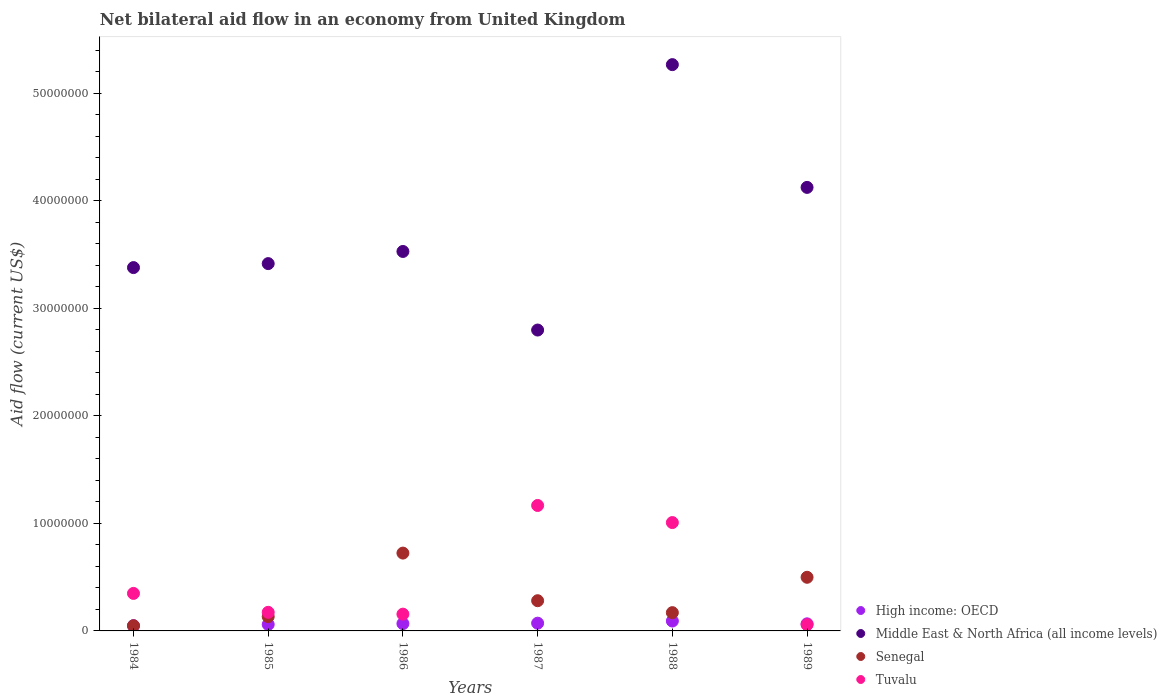How many different coloured dotlines are there?
Your answer should be compact. 4. Is the number of dotlines equal to the number of legend labels?
Your answer should be compact. Yes. What is the net bilateral aid flow in Senegal in 1985?
Your response must be concise. 1.33e+06. Across all years, what is the maximum net bilateral aid flow in Senegal?
Your response must be concise. 7.24e+06. In which year was the net bilateral aid flow in High income: OECD maximum?
Your answer should be compact. 1988. What is the total net bilateral aid flow in Middle East & North Africa (all income levels) in the graph?
Ensure brevity in your answer.  2.25e+08. What is the difference between the net bilateral aid flow in Senegal in 1987 and that in 1989?
Ensure brevity in your answer.  -2.18e+06. What is the difference between the net bilateral aid flow in Senegal in 1985 and the net bilateral aid flow in Middle East & North Africa (all income levels) in 1988?
Keep it short and to the point. -5.14e+07. What is the average net bilateral aid flow in Tuvalu per year?
Provide a short and direct response. 4.85e+06. In the year 1988, what is the difference between the net bilateral aid flow in Tuvalu and net bilateral aid flow in Senegal?
Keep it short and to the point. 8.38e+06. In how many years, is the net bilateral aid flow in High income: OECD greater than 28000000 US$?
Give a very brief answer. 0. What is the ratio of the net bilateral aid flow in Tuvalu in 1988 to that in 1989?
Offer a terse response. 17.38. Is the net bilateral aid flow in Middle East & North Africa (all income levels) in 1985 less than that in 1988?
Offer a very short reply. Yes. Is the difference between the net bilateral aid flow in Tuvalu in 1987 and 1988 greater than the difference between the net bilateral aid flow in Senegal in 1987 and 1988?
Your answer should be compact. Yes. What is the difference between the highest and the second highest net bilateral aid flow in Tuvalu?
Give a very brief answer. 1.59e+06. What is the difference between the highest and the lowest net bilateral aid flow in Senegal?
Provide a short and direct response. 6.76e+06. In how many years, is the net bilateral aid flow in Middle East & North Africa (all income levels) greater than the average net bilateral aid flow in Middle East & North Africa (all income levels) taken over all years?
Make the answer very short. 2. Is the sum of the net bilateral aid flow in Senegal in 1985 and 1988 greater than the maximum net bilateral aid flow in High income: OECD across all years?
Provide a succinct answer. Yes. Is it the case that in every year, the sum of the net bilateral aid flow in Senegal and net bilateral aid flow in High income: OECD  is greater than the net bilateral aid flow in Middle East & North Africa (all income levels)?
Offer a terse response. No. What is the title of the graph?
Give a very brief answer. Net bilateral aid flow in an economy from United Kingdom. Does "Korea (Democratic)" appear as one of the legend labels in the graph?
Provide a succinct answer. No. What is the label or title of the Y-axis?
Offer a terse response. Aid flow (current US$). What is the Aid flow (current US$) of High income: OECD in 1984?
Offer a terse response. 4.90e+05. What is the Aid flow (current US$) in Middle East & North Africa (all income levels) in 1984?
Provide a short and direct response. 3.38e+07. What is the Aid flow (current US$) in Senegal in 1984?
Offer a terse response. 4.80e+05. What is the Aid flow (current US$) in Tuvalu in 1984?
Provide a short and direct response. 3.49e+06. What is the Aid flow (current US$) in High income: OECD in 1985?
Offer a terse response. 6.00e+05. What is the Aid flow (current US$) in Middle East & North Africa (all income levels) in 1985?
Offer a terse response. 3.42e+07. What is the Aid flow (current US$) of Senegal in 1985?
Give a very brief answer. 1.33e+06. What is the Aid flow (current US$) in Tuvalu in 1985?
Offer a terse response. 1.73e+06. What is the Aid flow (current US$) in High income: OECD in 1986?
Ensure brevity in your answer.  6.80e+05. What is the Aid flow (current US$) in Middle East & North Africa (all income levels) in 1986?
Your answer should be very brief. 3.53e+07. What is the Aid flow (current US$) of Senegal in 1986?
Ensure brevity in your answer.  7.24e+06. What is the Aid flow (current US$) of Tuvalu in 1986?
Give a very brief answer. 1.56e+06. What is the Aid flow (current US$) of High income: OECD in 1987?
Provide a succinct answer. 7.20e+05. What is the Aid flow (current US$) in Middle East & North Africa (all income levels) in 1987?
Keep it short and to the point. 2.80e+07. What is the Aid flow (current US$) in Senegal in 1987?
Provide a succinct answer. 2.81e+06. What is the Aid flow (current US$) in Tuvalu in 1987?
Give a very brief answer. 1.17e+07. What is the Aid flow (current US$) in High income: OECD in 1988?
Provide a short and direct response. 9.20e+05. What is the Aid flow (current US$) in Middle East & North Africa (all income levels) in 1988?
Offer a terse response. 5.27e+07. What is the Aid flow (current US$) of Senegal in 1988?
Make the answer very short. 1.70e+06. What is the Aid flow (current US$) of Tuvalu in 1988?
Your response must be concise. 1.01e+07. What is the Aid flow (current US$) in High income: OECD in 1989?
Make the answer very short. 6.60e+05. What is the Aid flow (current US$) in Middle East & North Africa (all income levels) in 1989?
Provide a short and direct response. 4.13e+07. What is the Aid flow (current US$) of Senegal in 1989?
Your response must be concise. 4.99e+06. What is the Aid flow (current US$) of Tuvalu in 1989?
Make the answer very short. 5.80e+05. Across all years, what is the maximum Aid flow (current US$) of High income: OECD?
Your answer should be compact. 9.20e+05. Across all years, what is the maximum Aid flow (current US$) in Middle East & North Africa (all income levels)?
Offer a very short reply. 5.27e+07. Across all years, what is the maximum Aid flow (current US$) in Senegal?
Offer a very short reply. 7.24e+06. Across all years, what is the maximum Aid flow (current US$) in Tuvalu?
Provide a short and direct response. 1.17e+07. Across all years, what is the minimum Aid flow (current US$) of High income: OECD?
Offer a very short reply. 4.90e+05. Across all years, what is the minimum Aid flow (current US$) of Middle East & North Africa (all income levels)?
Keep it short and to the point. 2.80e+07. Across all years, what is the minimum Aid flow (current US$) in Tuvalu?
Offer a terse response. 5.80e+05. What is the total Aid flow (current US$) in High income: OECD in the graph?
Your answer should be compact. 4.07e+06. What is the total Aid flow (current US$) of Middle East & North Africa (all income levels) in the graph?
Give a very brief answer. 2.25e+08. What is the total Aid flow (current US$) of Senegal in the graph?
Provide a short and direct response. 1.86e+07. What is the total Aid flow (current US$) in Tuvalu in the graph?
Your answer should be very brief. 2.91e+07. What is the difference between the Aid flow (current US$) of Middle East & North Africa (all income levels) in 1984 and that in 1985?
Keep it short and to the point. -3.70e+05. What is the difference between the Aid flow (current US$) of Senegal in 1984 and that in 1985?
Give a very brief answer. -8.50e+05. What is the difference between the Aid flow (current US$) of Tuvalu in 1984 and that in 1985?
Offer a terse response. 1.76e+06. What is the difference between the Aid flow (current US$) in High income: OECD in 1984 and that in 1986?
Your response must be concise. -1.90e+05. What is the difference between the Aid flow (current US$) in Middle East & North Africa (all income levels) in 1984 and that in 1986?
Offer a terse response. -1.50e+06. What is the difference between the Aid flow (current US$) of Senegal in 1984 and that in 1986?
Provide a short and direct response. -6.76e+06. What is the difference between the Aid flow (current US$) of Tuvalu in 1984 and that in 1986?
Provide a short and direct response. 1.93e+06. What is the difference between the Aid flow (current US$) in Middle East & North Africa (all income levels) in 1984 and that in 1987?
Make the answer very short. 5.81e+06. What is the difference between the Aid flow (current US$) in Senegal in 1984 and that in 1987?
Your answer should be very brief. -2.33e+06. What is the difference between the Aid flow (current US$) of Tuvalu in 1984 and that in 1987?
Your response must be concise. -8.18e+06. What is the difference between the Aid flow (current US$) of High income: OECD in 1984 and that in 1988?
Your answer should be compact. -4.30e+05. What is the difference between the Aid flow (current US$) of Middle East & North Africa (all income levels) in 1984 and that in 1988?
Provide a succinct answer. -1.89e+07. What is the difference between the Aid flow (current US$) in Senegal in 1984 and that in 1988?
Offer a very short reply. -1.22e+06. What is the difference between the Aid flow (current US$) of Tuvalu in 1984 and that in 1988?
Provide a succinct answer. -6.59e+06. What is the difference between the Aid flow (current US$) in Middle East & North Africa (all income levels) in 1984 and that in 1989?
Ensure brevity in your answer.  -7.46e+06. What is the difference between the Aid flow (current US$) of Senegal in 1984 and that in 1989?
Provide a succinct answer. -4.51e+06. What is the difference between the Aid flow (current US$) of Tuvalu in 1984 and that in 1989?
Give a very brief answer. 2.91e+06. What is the difference between the Aid flow (current US$) in Middle East & North Africa (all income levels) in 1985 and that in 1986?
Your answer should be very brief. -1.13e+06. What is the difference between the Aid flow (current US$) of Senegal in 1985 and that in 1986?
Your answer should be very brief. -5.91e+06. What is the difference between the Aid flow (current US$) of Tuvalu in 1985 and that in 1986?
Provide a short and direct response. 1.70e+05. What is the difference between the Aid flow (current US$) in High income: OECD in 1985 and that in 1987?
Provide a short and direct response. -1.20e+05. What is the difference between the Aid flow (current US$) of Middle East & North Africa (all income levels) in 1985 and that in 1987?
Give a very brief answer. 6.18e+06. What is the difference between the Aid flow (current US$) of Senegal in 1985 and that in 1987?
Keep it short and to the point. -1.48e+06. What is the difference between the Aid flow (current US$) in Tuvalu in 1985 and that in 1987?
Offer a very short reply. -9.94e+06. What is the difference between the Aid flow (current US$) in High income: OECD in 1985 and that in 1988?
Provide a short and direct response. -3.20e+05. What is the difference between the Aid flow (current US$) of Middle East & North Africa (all income levels) in 1985 and that in 1988?
Provide a succinct answer. -1.85e+07. What is the difference between the Aid flow (current US$) of Senegal in 1985 and that in 1988?
Ensure brevity in your answer.  -3.70e+05. What is the difference between the Aid flow (current US$) in Tuvalu in 1985 and that in 1988?
Give a very brief answer. -8.35e+06. What is the difference between the Aid flow (current US$) of Middle East & North Africa (all income levels) in 1985 and that in 1989?
Your answer should be very brief. -7.09e+06. What is the difference between the Aid flow (current US$) in Senegal in 1985 and that in 1989?
Provide a succinct answer. -3.66e+06. What is the difference between the Aid flow (current US$) of Tuvalu in 1985 and that in 1989?
Give a very brief answer. 1.15e+06. What is the difference between the Aid flow (current US$) in High income: OECD in 1986 and that in 1987?
Your answer should be compact. -4.00e+04. What is the difference between the Aid flow (current US$) in Middle East & North Africa (all income levels) in 1986 and that in 1987?
Provide a succinct answer. 7.31e+06. What is the difference between the Aid flow (current US$) in Senegal in 1986 and that in 1987?
Give a very brief answer. 4.43e+06. What is the difference between the Aid flow (current US$) of Tuvalu in 1986 and that in 1987?
Keep it short and to the point. -1.01e+07. What is the difference between the Aid flow (current US$) in Middle East & North Africa (all income levels) in 1986 and that in 1988?
Ensure brevity in your answer.  -1.74e+07. What is the difference between the Aid flow (current US$) in Senegal in 1986 and that in 1988?
Your answer should be very brief. 5.54e+06. What is the difference between the Aid flow (current US$) of Tuvalu in 1986 and that in 1988?
Your answer should be very brief. -8.52e+06. What is the difference between the Aid flow (current US$) in Middle East & North Africa (all income levels) in 1986 and that in 1989?
Provide a succinct answer. -5.96e+06. What is the difference between the Aid flow (current US$) of Senegal in 1986 and that in 1989?
Give a very brief answer. 2.25e+06. What is the difference between the Aid flow (current US$) in Tuvalu in 1986 and that in 1989?
Your response must be concise. 9.80e+05. What is the difference between the Aid flow (current US$) in Middle East & North Africa (all income levels) in 1987 and that in 1988?
Make the answer very short. -2.47e+07. What is the difference between the Aid flow (current US$) of Senegal in 1987 and that in 1988?
Provide a succinct answer. 1.11e+06. What is the difference between the Aid flow (current US$) of Tuvalu in 1987 and that in 1988?
Provide a short and direct response. 1.59e+06. What is the difference between the Aid flow (current US$) of High income: OECD in 1987 and that in 1989?
Keep it short and to the point. 6.00e+04. What is the difference between the Aid flow (current US$) of Middle East & North Africa (all income levels) in 1987 and that in 1989?
Make the answer very short. -1.33e+07. What is the difference between the Aid flow (current US$) of Senegal in 1987 and that in 1989?
Offer a very short reply. -2.18e+06. What is the difference between the Aid flow (current US$) in Tuvalu in 1987 and that in 1989?
Keep it short and to the point. 1.11e+07. What is the difference between the Aid flow (current US$) in High income: OECD in 1988 and that in 1989?
Offer a terse response. 2.60e+05. What is the difference between the Aid flow (current US$) in Middle East & North Africa (all income levels) in 1988 and that in 1989?
Provide a short and direct response. 1.14e+07. What is the difference between the Aid flow (current US$) of Senegal in 1988 and that in 1989?
Offer a terse response. -3.29e+06. What is the difference between the Aid flow (current US$) in Tuvalu in 1988 and that in 1989?
Your answer should be very brief. 9.50e+06. What is the difference between the Aid flow (current US$) of High income: OECD in 1984 and the Aid flow (current US$) of Middle East & North Africa (all income levels) in 1985?
Ensure brevity in your answer.  -3.37e+07. What is the difference between the Aid flow (current US$) of High income: OECD in 1984 and the Aid flow (current US$) of Senegal in 1985?
Your answer should be very brief. -8.40e+05. What is the difference between the Aid flow (current US$) of High income: OECD in 1984 and the Aid flow (current US$) of Tuvalu in 1985?
Offer a terse response. -1.24e+06. What is the difference between the Aid flow (current US$) in Middle East & North Africa (all income levels) in 1984 and the Aid flow (current US$) in Senegal in 1985?
Offer a very short reply. 3.25e+07. What is the difference between the Aid flow (current US$) of Middle East & North Africa (all income levels) in 1984 and the Aid flow (current US$) of Tuvalu in 1985?
Make the answer very short. 3.21e+07. What is the difference between the Aid flow (current US$) of Senegal in 1984 and the Aid flow (current US$) of Tuvalu in 1985?
Your response must be concise. -1.25e+06. What is the difference between the Aid flow (current US$) of High income: OECD in 1984 and the Aid flow (current US$) of Middle East & North Africa (all income levels) in 1986?
Make the answer very short. -3.48e+07. What is the difference between the Aid flow (current US$) of High income: OECD in 1984 and the Aid flow (current US$) of Senegal in 1986?
Make the answer very short. -6.75e+06. What is the difference between the Aid flow (current US$) of High income: OECD in 1984 and the Aid flow (current US$) of Tuvalu in 1986?
Offer a terse response. -1.07e+06. What is the difference between the Aid flow (current US$) in Middle East & North Africa (all income levels) in 1984 and the Aid flow (current US$) in Senegal in 1986?
Your answer should be compact. 2.66e+07. What is the difference between the Aid flow (current US$) in Middle East & North Africa (all income levels) in 1984 and the Aid flow (current US$) in Tuvalu in 1986?
Keep it short and to the point. 3.22e+07. What is the difference between the Aid flow (current US$) in Senegal in 1984 and the Aid flow (current US$) in Tuvalu in 1986?
Ensure brevity in your answer.  -1.08e+06. What is the difference between the Aid flow (current US$) of High income: OECD in 1984 and the Aid flow (current US$) of Middle East & North Africa (all income levels) in 1987?
Your response must be concise. -2.75e+07. What is the difference between the Aid flow (current US$) in High income: OECD in 1984 and the Aid flow (current US$) in Senegal in 1987?
Your response must be concise. -2.32e+06. What is the difference between the Aid flow (current US$) in High income: OECD in 1984 and the Aid flow (current US$) in Tuvalu in 1987?
Your answer should be very brief. -1.12e+07. What is the difference between the Aid flow (current US$) in Middle East & North Africa (all income levels) in 1984 and the Aid flow (current US$) in Senegal in 1987?
Offer a terse response. 3.10e+07. What is the difference between the Aid flow (current US$) of Middle East & North Africa (all income levels) in 1984 and the Aid flow (current US$) of Tuvalu in 1987?
Your answer should be very brief. 2.21e+07. What is the difference between the Aid flow (current US$) of Senegal in 1984 and the Aid flow (current US$) of Tuvalu in 1987?
Make the answer very short. -1.12e+07. What is the difference between the Aid flow (current US$) in High income: OECD in 1984 and the Aid flow (current US$) in Middle East & North Africa (all income levels) in 1988?
Make the answer very short. -5.22e+07. What is the difference between the Aid flow (current US$) of High income: OECD in 1984 and the Aid flow (current US$) of Senegal in 1988?
Give a very brief answer. -1.21e+06. What is the difference between the Aid flow (current US$) of High income: OECD in 1984 and the Aid flow (current US$) of Tuvalu in 1988?
Offer a very short reply. -9.59e+06. What is the difference between the Aid flow (current US$) of Middle East & North Africa (all income levels) in 1984 and the Aid flow (current US$) of Senegal in 1988?
Ensure brevity in your answer.  3.21e+07. What is the difference between the Aid flow (current US$) in Middle East & North Africa (all income levels) in 1984 and the Aid flow (current US$) in Tuvalu in 1988?
Give a very brief answer. 2.37e+07. What is the difference between the Aid flow (current US$) of Senegal in 1984 and the Aid flow (current US$) of Tuvalu in 1988?
Ensure brevity in your answer.  -9.60e+06. What is the difference between the Aid flow (current US$) of High income: OECD in 1984 and the Aid flow (current US$) of Middle East & North Africa (all income levels) in 1989?
Your response must be concise. -4.08e+07. What is the difference between the Aid flow (current US$) in High income: OECD in 1984 and the Aid flow (current US$) in Senegal in 1989?
Offer a very short reply. -4.50e+06. What is the difference between the Aid flow (current US$) in High income: OECD in 1984 and the Aid flow (current US$) in Tuvalu in 1989?
Ensure brevity in your answer.  -9.00e+04. What is the difference between the Aid flow (current US$) in Middle East & North Africa (all income levels) in 1984 and the Aid flow (current US$) in Senegal in 1989?
Make the answer very short. 2.88e+07. What is the difference between the Aid flow (current US$) of Middle East & North Africa (all income levels) in 1984 and the Aid flow (current US$) of Tuvalu in 1989?
Your response must be concise. 3.32e+07. What is the difference between the Aid flow (current US$) of High income: OECD in 1985 and the Aid flow (current US$) of Middle East & North Africa (all income levels) in 1986?
Offer a very short reply. -3.47e+07. What is the difference between the Aid flow (current US$) of High income: OECD in 1985 and the Aid flow (current US$) of Senegal in 1986?
Give a very brief answer. -6.64e+06. What is the difference between the Aid flow (current US$) of High income: OECD in 1985 and the Aid flow (current US$) of Tuvalu in 1986?
Your response must be concise. -9.60e+05. What is the difference between the Aid flow (current US$) in Middle East & North Africa (all income levels) in 1985 and the Aid flow (current US$) in Senegal in 1986?
Provide a succinct answer. 2.69e+07. What is the difference between the Aid flow (current US$) in Middle East & North Africa (all income levels) in 1985 and the Aid flow (current US$) in Tuvalu in 1986?
Offer a terse response. 3.26e+07. What is the difference between the Aid flow (current US$) in Senegal in 1985 and the Aid flow (current US$) in Tuvalu in 1986?
Your response must be concise. -2.30e+05. What is the difference between the Aid flow (current US$) of High income: OECD in 1985 and the Aid flow (current US$) of Middle East & North Africa (all income levels) in 1987?
Your answer should be compact. -2.74e+07. What is the difference between the Aid flow (current US$) of High income: OECD in 1985 and the Aid flow (current US$) of Senegal in 1987?
Ensure brevity in your answer.  -2.21e+06. What is the difference between the Aid flow (current US$) of High income: OECD in 1985 and the Aid flow (current US$) of Tuvalu in 1987?
Make the answer very short. -1.11e+07. What is the difference between the Aid flow (current US$) in Middle East & North Africa (all income levels) in 1985 and the Aid flow (current US$) in Senegal in 1987?
Provide a succinct answer. 3.14e+07. What is the difference between the Aid flow (current US$) in Middle East & North Africa (all income levels) in 1985 and the Aid flow (current US$) in Tuvalu in 1987?
Ensure brevity in your answer.  2.25e+07. What is the difference between the Aid flow (current US$) in Senegal in 1985 and the Aid flow (current US$) in Tuvalu in 1987?
Keep it short and to the point. -1.03e+07. What is the difference between the Aid flow (current US$) of High income: OECD in 1985 and the Aid flow (current US$) of Middle East & North Africa (all income levels) in 1988?
Your response must be concise. -5.21e+07. What is the difference between the Aid flow (current US$) in High income: OECD in 1985 and the Aid flow (current US$) in Senegal in 1988?
Give a very brief answer. -1.10e+06. What is the difference between the Aid flow (current US$) in High income: OECD in 1985 and the Aid flow (current US$) in Tuvalu in 1988?
Your response must be concise. -9.48e+06. What is the difference between the Aid flow (current US$) in Middle East & North Africa (all income levels) in 1985 and the Aid flow (current US$) in Senegal in 1988?
Your answer should be compact. 3.25e+07. What is the difference between the Aid flow (current US$) in Middle East & North Africa (all income levels) in 1985 and the Aid flow (current US$) in Tuvalu in 1988?
Your response must be concise. 2.41e+07. What is the difference between the Aid flow (current US$) in Senegal in 1985 and the Aid flow (current US$) in Tuvalu in 1988?
Provide a succinct answer. -8.75e+06. What is the difference between the Aid flow (current US$) of High income: OECD in 1985 and the Aid flow (current US$) of Middle East & North Africa (all income levels) in 1989?
Offer a very short reply. -4.07e+07. What is the difference between the Aid flow (current US$) of High income: OECD in 1985 and the Aid flow (current US$) of Senegal in 1989?
Your answer should be very brief. -4.39e+06. What is the difference between the Aid flow (current US$) of High income: OECD in 1985 and the Aid flow (current US$) of Tuvalu in 1989?
Keep it short and to the point. 2.00e+04. What is the difference between the Aid flow (current US$) in Middle East & North Africa (all income levels) in 1985 and the Aid flow (current US$) in Senegal in 1989?
Offer a terse response. 2.92e+07. What is the difference between the Aid flow (current US$) of Middle East & North Africa (all income levels) in 1985 and the Aid flow (current US$) of Tuvalu in 1989?
Ensure brevity in your answer.  3.36e+07. What is the difference between the Aid flow (current US$) of Senegal in 1985 and the Aid flow (current US$) of Tuvalu in 1989?
Your answer should be very brief. 7.50e+05. What is the difference between the Aid flow (current US$) of High income: OECD in 1986 and the Aid flow (current US$) of Middle East & North Africa (all income levels) in 1987?
Your answer should be compact. -2.73e+07. What is the difference between the Aid flow (current US$) in High income: OECD in 1986 and the Aid flow (current US$) in Senegal in 1987?
Make the answer very short. -2.13e+06. What is the difference between the Aid flow (current US$) of High income: OECD in 1986 and the Aid flow (current US$) of Tuvalu in 1987?
Offer a terse response. -1.10e+07. What is the difference between the Aid flow (current US$) of Middle East & North Africa (all income levels) in 1986 and the Aid flow (current US$) of Senegal in 1987?
Your answer should be compact. 3.25e+07. What is the difference between the Aid flow (current US$) in Middle East & North Africa (all income levels) in 1986 and the Aid flow (current US$) in Tuvalu in 1987?
Your answer should be very brief. 2.36e+07. What is the difference between the Aid flow (current US$) of Senegal in 1986 and the Aid flow (current US$) of Tuvalu in 1987?
Ensure brevity in your answer.  -4.43e+06. What is the difference between the Aid flow (current US$) of High income: OECD in 1986 and the Aid flow (current US$) of Middle East & North Africa (all income levels) in 1988?
Your answer should be very brief. -5.20e+07. What is the difference between the Aid flow (current US$) in High income: OECD in 1986 and the Aid flow (current US$) in Senegal in 1988?
Offer a terse response. -1.02e+06. What is the difference between the Aid flow (current US$) of High income: OECD in 1986 and the Aid flow (current US$) of Tuvalu in 1988?
Your answer should be very brief. -9.40e+06. What is the difference between the Aid flow (current US$) in Middle East & North Africa (all income levels) in 1986 and the Aid flow (current US$) in Senegal in 1988?
Offer a terse response. 3.36e+07. What is the difference between the Aid flow (current US$) in Middle East & North Africa (all income levels) in 1986 and the Aid flow (current US$) in Tuvalu in 1988?
Your response must be concise. 2.52e+07. What is the difference between the Aid flow (current US$) in Senegal in 1986 and the Aid flow (current US$) in Tuvalu in 1988?
Provide a succinct answer. -2.84e+06. What is the difference between the Aid flow (current US$) of High income: OECD in 1986 and the Aid flow (current US$) of Middle East & North Africa (all income levels) in 1989?
Make the answer very short. -4.06e+07. What is the difference between the Aid flow (current US$) in High income: OECD in 1986 and the Aid flow (current US$) in Senegal in 1989?
Your answer should be compact. -4.31e+06. What is the difference between the Aid flow (current US$) of Middle East & North Africa (all income levels) in 1986 and the Aid flow (current US$) of Senegal in 1989?
Keep it short and to the point. 3.03e+07. What is the difference between the Aid flow (current US$) in Middle East & North Africa (all income levels) in 1986 and the Aid flow (current US$) in Tuvalu in 1989?
Your response must be concise. 3.47e+07. What is the difference between the Aid flow (current US$) of Senegal in 1986 and the Aid flow (current US$) of Tuvalu in 1989?
Provide a short and direct response. 6.66e+06. What is the difference between the Aid flow (current US$) of High income: OECD in 1987 and the Aid flow (current US$) of Middle East & North Africa (all income levels) in 1988?
Ensure brevity in your answer.  -5.20e+07. What is the difference between the Aid flow (current US$) in High income: OECD in 1987 and the Aid flow (current US$) in Senegal in 1988?
Provide a short and direct response. -9.80e+05. What is the difference between the Aid flow (current US$) in High income: OECD in 1987 and the Aid flow (current US$) in Tuvalu in 1988?
Your response must be concise. -9.36e+06. What is the difference between the Aid flow (current US$) of Middle East & North Africa (all income levels) in 1987 and the Aid flow (current US$) of Senegal in 1988?
Your response must be concise. 2.63e+07. What is the difference between the Aid flow (current US$) of Middle East & North Africa (all income levels) in 1987 and the Aid flow (current US$) of Tuvalu in 1988?
Ensure brevity in your answer.  1.79e+07. What is the difference between the Aid flow (current US$) of Senegal in 1987 and the Aid flow (current US$) of Tuvalu in 1988?
Provide a succinct answer. -7.27e+06. What is the difference between the Aid flow (current US$) of High income: OECD in 1987 and the Aid flow (current US$) of Middle East & North Africa (all income levels) in 1989?
Provide a succinct answer. -4.05e+07. What is the difference between the Aid flow (current US$) in High income: OECD in 1987 and the Aid flow (current US$) in Senegal in 1989?
Provide a short and direct response. -4.27e+06. What is the difference between the Aid flow (current US$) in High income: OECD in 1987 and the Aid flow (current US$) in Tuvalu in 1989?
Your answer should be compact. 1.40e+05. What is the difference between the Aid flow (current US$) in Middle East & North Africa (all income levels) in 1987 and the Aid flow (current US$) in Senegal in 1989?
Give a very brief answer. 2.30e+07. What is the difference between the Aid flow (current US$) of Middle East & North Africa (all income levels) in 1987 and the Aid flow (current US$) of Tuvalu in 1989?
Offer a very short reply. 2.74e+07. What is the difference between the Aid flow (current US$) in Senegal in 1987 and the Aid flow (current US$) in Tuvalu in 1989?
Your answer should be compact. 2.23e+06. What is the difference between the Aid flow (current US$) in High income: OECD in 1988 and the Aid flow (current US$) in Middle East & North Africa (all income levels) in 1989?
Give a very brief answer. -4.03e+07. What is the difference between the Aid flow (current US$) in High income: OECD in 1988 and the Aid flow (current US$) in Senegal in 1989?
Keep it short and to the point. -4.07e+06. What is the difference between the Aid flow (current US$) of High income: OECD in 1988 and the Aid flow (current US$) of Tuvalu in 1989?
Your answer should be very brief. 3.40e+05. What is the difference between the Aid flow (current US$) of Middle East & North Africa (all income levels) in 1988 and the Aid flow (current US$) of Senegal in 1989?
Your answer should be very brief. 4.77e+07. What is the difference between the Aid flow (current US$) in Middle East & North Africa (all income levels) in 1988 and the Aid flow (current US$) in Tuvalu in 1989?
Offer a terse response. 5.21e+07. What is the difference between the Aid flow (current US$) of Senegal in 1988 and the Aid flow (current US$) of Tuvalu in 1989?
Your response must be concise. 1.12e+06. What is the average Aid flow (current US$) of High income: OECD per year?
Provide a short and direct response. 6.78e+05. What is the average Aid flow (current US$) in Middle East & North Africa (all income levels) per year?
Keep it short and to the point. 3.75e+07. What is the average Aid flow (current US$) of Senegal per year?
Your response must be concise. 3.09e+06. What is the average Aid flow (current US$) of Tuvalu per year?
Provide a succinct answer. 4.85e+06. In the year 1984, what is the difference between the Aid flow (current US$) in High income: OECD and Aid flow (current US$) in Middle East & North Africa (all income levels)?
Your response must be concise. -3.33e+07. In the year 1984, what is the difference between the Aid flow (current US$) of High income: OECD and Aid flow (current US$) of Senegal?
Offer a terse response. 10000. In the year 1984, what is the difference between the Aid flow (current US$) of High income: OECD and Aid flow (current US$) of Tuvalu?
Your answer should be very brief. -3.00e+06. In the year 1984, what is the difference between the Aid flow (current US$) of Middle East & North Africa (all income levels) and Aid flow (current US$) of Senegal?
Ensure brevity in your answer.  3.33e+07. In the year 1984, what is the difference between the Aid flow (current US$) in Middle East & North Africa (all income levels) and Aid flow (current US$) in Tuvalu?
Provide a succinct answer. 3.03e+07. In the year 1984, what is the difference between the Aid flow (current US$) in Senegal and Aid flow (current US$) in Tuvalu?
Your response must be concise. -3.01e+06. In the year 1985, what is the difference between the Aid flow (current US$) in High income: OECD and Aid flow (current US$) in Middle East & North Africa (all income levels)?
Ensure brevity in your answer.  -3.36e+07. In the year 1985, what is the difference between the Aid flow (current US$) in High income: OECD and Aid flow (current US$) in Senegal?
Ensure brevity in your answer.  -7.30e+05. In the year 1985, what is the difference between the Aid flow (current US$) in High income: OECD and Aid flow (current US$) in Tuvalu?
Keep it short and to the point. -1.13e+06. In the year 1985, what is the difference between the Aid flow (current US$) in Middle East & North Africa (all income levels) and Aid flow (current US$) in Senegal?
Ensure brevity in your answer.  3.28e+07. In the year 1985, what is the difference between the Aid flow (current US$) in Middle East & North Africa (all income levels) and Aid flow (current US$) in Tuvalu?
Your answer should be compact. 3.24e+07. In the year 1985, what is the difference between the Aid flow (current US$) in Senegal and Aid flow (current US$) in Tuvalu?
Offer a terse response. -4.00e+05. In the year 1986, what is the difference between the Aid flow (current US$) of High income: OECD and Aid flow (current US$) of Middle East & North Africa (all income levels)?
Offer a very short reply. -3.46e+07. In the year 1986, what is the difference between the Aid flow (current US$) in High income: OECD and Aid flow (current US$) in Senegal?
Make the answer very short. -6.56e+06. In the year 1986, what is the difference between the Aid flow (current US$) of High income: OECD and Aid flow (current US$) of Tuvalu?
Provide a succinct answer. -8.80e+05. In the year 1986, what is the difference between the Aid flow (current US$) in Middle East & North Africa (all income levels) and Aid flow (current US$) in Senegal?
Provide a succinct answer. 2.81e+07. In the year 1986, what is the difference between the Aid flow (current US$) in Middle East & North Africa (all income levels) and Aid flow (current US$) in Tuvalu?
Provide a short and direct response. 3.37e+07. In the year 1986, what is the difference between the Aid flow (current US$) of Senegal and Aid flow (current US$) of Tuvalu?
Your answer should be very brief. 5.68e+06. In the year 1987, what is the difference between the Aid flow (current US$) in High income: OECD and Aid flow (current US$) in Middle East & North Africa (all income levels)?
Provide a succinct answer. -2.73e+07. In the year 1987, what is the difference between the Aid flow (current US$) of High income: OECD and Aid flow (current US$) of Senegal?
Keep it short and to the point. -2.09e+06. In the year 1987, what is the difference between the Aid flow (current US$) in High income: OECD and Aid flow (current US$) in Tuvalu?
Give a very brief answer. -1.10e+07. In the year 1987, what is the difference between the Aid flow (current US$) of Middle East & North Africa (all income levels) and Aid flow (current US$) of Senegal?
Ensure brevity in your answer.  2.52e+07. In the year 1987, what is the difference between the Aid flow (current US$) in Middle East & North Africa (all income levels) and Aid flow (current US$) in Tuvalu?
Offer a very short reply. 1.63e+07. In the year 1987, what is the difference between the Aid flow (current US$) in Senegal and Aid flow (current US$) in Tuvalu?
Provide a short and direct response. -8.86e+06. In the year 1988, what is the difference between the Aid flow (current US$) in High income: OECD and Aid flow (current US$) in Middle East & North Africa (all income levels)?
Your response must be concise. -5.18e+07. In the year 1988, what is the difference between the Aid flow (current US$) in High income: OECD and Aid flow (current US$) in Senegal?
Make the answer very short. -7.80e+05. In the year 1988, what is the difference between the Aid flow (current US$) in High income: OECD and Aid flow (current US$) in Tuvalu?
Your response must be concise. -9.16e+06. In the year 1988, what is the difference between the Aid flow (current US$) of Middle East & North Africa (all income levels) and Aid flow (current US$) of Senegal?
Provide a succinct answer. 5.10e+07. In the year 1988, what is the difference between the Aid flow (current US$) in Middle East & North Africa (all income levels) and Aid flow (current US$) in Tuvalu?
Your answer should be very brief. 4.26e+07. In the year 1988, what is the difference between the Aid flow (current US$) in Senegal and Aid flow (current US$) in Tuvalu?
Make the answer very short. -8.38e+06. In the year 1989, what is the difference between the Aid flow (current US$) in High income: OECD and Aid flow (current US$) in Middle East & North Africa (all income levels)?
Make the answer very short. -4.06e+07. In the year 1989, what is the difference between the Aid flow (current US$) of High income: OECD and Aid flow (current US$) of Senegal?
Provide a succinct answer. -4.33e+06. In the year 1989, what is the difference between the Aid flow (current US$) of Middle East & North Africa (all income levels) and Aid flow (current US$) of Senegal?
Your answer should be compact. 3.63e+07. In the year 1989, what is the difference between the Aid flow (current US$) of Middle East & North Africa (all income levels) and Aid flow (current US$) of Tuvalu?
Your answer should be very brief. 4.07e+07. In the year 1989, what is the difference between the Aid flow (current US$) of Senegal and Aid flow (current US$) of Tuvalu?
Your answer should be compact. 4.41e+06. What is the ratio of the Aid flow (current US$) of High income: OECD in 1984 to that in 1985?
Offer a very short reply. 0.82. What is the ratio of the Aid flow (current US$) of Senegal in 1984 to that in 1985?
Make the answer very short. 0.36. What is the ratio of the Aid flow (current US$) of Tuvalu in 1984 to that in 1985?
Your answer should be compact. 2.02. What is the ratio of the Aid flow (current US$) of High income: OECD in 1984 to that in 1986?
Offer a very short reply. 0.72. What is the ratio of the Aid flow (current US$) in Middle East & North Africa (all income levels) in 1984 to that in 1986?
Offer a terse response. 0.96. What is the ratio of the Aid flow (current US$) of Senegal in 1984 to that in 1986?
Ensure brevity in your answer.  0.07. What is the ratio of the Aid flow (current US$) in Tuvalu in 1984 to that in 1986?
Your answer should be compact. 2.24. What is the ratio of the Aid flow (current US$) in High income: OECD in 1984 to that in 1987?
Offer a very short reply. 0.68. What is the ratio of the Aid flow (current US$) in Middle East & North Africa (all income levels) in 1984 to that in 1987?
Keep it short and to the point. 1.21. What is the ratio of the Aid flow (current US$) of Senegal in 1984 to that in 1987?
Provide a succinct answer. 0.17. What is the ratio of the Aid flow (current US$) in Tuvalu in 1984 to that in 1987?
Offer a terse response. 0.3. What is the ratio of the Aid flow (current US$) in High income: OECD in 1984 to that in 1988?
Provide a succinct answer. 0.53. What is the ratio of the Aid flow (current US$) of Middle East & North Africa (all income levels) in 1984 to that in 1988?
Your answer should be very brief. 0.64. What is the ratio of the Aid flow (current US$) of Senegal in 1984 to that in 1988?
Your answer should be very brief. 0.28. What is the ratio of the Aid flow (current US$) of Tuvalu in 1984 to that in 1988?
Give a very brief answer. 0.35. What is the ratio of the Aid flow (current US$) of High income: OECD in 1984 to that in 1989?
Your answer should be very brief. 0.74. What is the ratio of the Aid flow (current US$) in Middle East & North Africa (all income levels) in 1984 to that in 1989?
Your answer should be compact. 0.82. What is the ratio of the Aid flow (current US$) in Senegal in 1984 to that in 1989?
Ensure brevity in your answer.  0.1. What is the ratio of the Aid flow (current US$) in Tuvalu in 1984 to that in 1989?
Give a very brief answer. 6.02. What is the ratio of the Aid flow (current US$) in High income: OECD in 1985 to that in 1986?
Your response must be concise. 0.88. What is the ratio of the Aid flow (current US$) in Middle East & North Africa (all income levels) in 1985 to that in 1986?
Provide a succinct answer. 0.97. What is the ratio of the Aid flow (current US$) in Senegal in 1985 to that in 1986?
Offer a very short reply. 0.18. What is the ratio of the Aid flow (current US$) of Tuvalu in 1985 to that in 1986?
Your answer should be very brief. 1.11. What is the ratio of the Aid flow (current US$) in Middle East & North Africa (all income levels) in 1985 to that in 1987?
Your answer should be very brief. 1.22. What is the ratio of the Aid flow (current US$) of Senegal in 1985 to that in 1987?
Your answer should be compact. 0.47. What is the ratio of the Aid flow (current US$) in Tuvalu in 1985 to that in 1987?
Keep it short and to the point. 0.15. What is the ratio of the Aid flow (current US$) of High income: OECD in 1985 to that in 1988?
Ensure brevity in your answer.  0.65. What is the ratio of the Aid flow (current US$) of Middle East & North Africa (all income levels) in 1985 to that in 1988?
Your answer should be compact. 0.65. What is the ratio of the Aid flow (current US$) in Senegal in 1985 to that in 1988?
Make the answer very short. 0.78. What is the ratio of the Aid flow (current US$) of Tuvalu in 1985 to that in 1988?
Provide a succinct answer. 0.17. What is the ratio of the Aid flow (current US$) in High income: OECD in 1985 to that in 1989?
Provide a short and direct response. 0.91. What is the ratio of the Aid flow (current US$) in Middle East & North Africa (all income levels) in 1985 to that in 1989?
Ensure brevity in your answer.  0.83. What is the ratio of the Aid flow (current US$) in Senegal in 1985 to that in 1989?
Provide a short and direct response. 0.27. What is the ratio of the Aid flow (current US$) in Tuvalu in 1985 to that in 1989?
Offer a very short reply. 2.98. What is the ratio of the Aid flow (current US$) in Middle East & North Africa (all income levels) in 1986 to that in 1987?
Your answer should be compact. 1.26. What is the ratio of the Aid flow (current US$) of Senegal in 1986 to that in 1987?
Provide a succinct answer. 2.58. What is the ratio of the Aid flow (current US$) of Tuvalu in 1986 to that in 1987?
Ensure brevity in your answer.  0.13. What is the ratio of the Aid flow (current US$) of High income: OECD in 1986 to that in 1988?
Ensure brevity in your answer.  0.74. What is the ratio of the Aid flow (current US$) in Middle East & North Africa (all income levels) in 1986 to that in 1988?
Provide a succinct answer. 0.67. What is the ratio of the Aid flow (current US$) of Senegal in 1986 to that in 1988?
Make the answer very short. 4.26. What is the ratio of the Aid flow (current US$) of Tuvalu in 1986 to that in 1988?
Your answer should be compact. 0.15. What is the ratio of the Aid flow (current US$) in High income: OECD in 1986 to that in 1989?
Give a very brief answer. 1.03. What is the ratio of the Aid flow (current US$) of Middle East & North Africa (all income levels) in 1986 to that in 1989?
Your answer should be very brief. 0.86. What is the ratio of the Aid flow (current US$) in Senegal in 1986 to that in 1989?
Offer a terse response. 1.45. What is the ratio of the Aid flow (current US$) in Tuvalu in 1986 to that in 1989?
Ensure brevity in your answer.  2.69. What is the ratio of the Aid flow (current US$) of High income: OECD in 1987 to that in 1988?
Give a very brief answer. 0.78. What is the ratio of the Aid flow (current US$) in Middle East & North Africa (all income levels) in 1987 to that in 1988?
Provide a short and direct response. 0.53. What is the ratio of the Aid flow (current US$) in Senegal in 1987 to that in 1988?
Your answer should be very brief. 1.65. What is the ratio of the Aid flow (current US$) of Tuvalu in 1987 to that in 1988?
Give a very brief answer. 1.16. What is the ratio of the Aid flow (current US$) in Middle East & North Africa (all income levels) in 1987 to that in 1989?
Offer a terse response. 0.68. What is the ratio of the Aid flow (current US$) in Senegal in 1987 to that in 1989?
Ensure brevity in your answer.  0.56. What is the ratio of the Aid flow (current US$) of Tuvalu in 1987 to that in 1989?
Provide a short and direct response. 20.12. What is the ratio of the Aid flow (current US$) in High income: OECD in 1988 to that in 1989?
Keep it short and to the point. 1.39. What is the ratio of the Aid flow (current US$) of Middle East & North Africa (all income levels) in 1988 to that in 1989?
Provide a short and direct response. 1.28. What is the ratio of the Aid flow (current US$) in Senegal in 1988 to that in 1989?
Provide a short and direct response. 0.34. What is the ratio of the Aid flow (current US$) of Tuvalu in 1988 to that in 1989?
Make the answer very short. 17.38. What is the difference between the highest and the second highest Aid flow (current US$) of High income: OECD?
Provide a short and direct response. 2.00e+05. What is the difference between the highest and the second highest Aid flow (current US$) in Middle East & North Africa (all income levels)?
Your answer should be compact. 1.14e+07. What is the difference between the highest and the second highest Aid flow (current US$) in Senegal?
Your answer should be compact. 2.25e+06. What is the difference between the highest and the second highest Aid flow (current US$) in Tuvalu?
Keep it short and to the point. 1.59e+06. What is the difference between the highest and the lowest Aid flow (current US$) of Middle East & North Africa (all income levels)?
Your response must be concise. 2.47e+07. What is the difference between the highest and the lowest Aid flow (current US$) in Senegal?
Offer a very short reply. 6.76e+06. What is the difference between the highest and the lowest Aid flow (current US$) of Tuvalu?
Your answer should be very brief. 1.11e+07. 